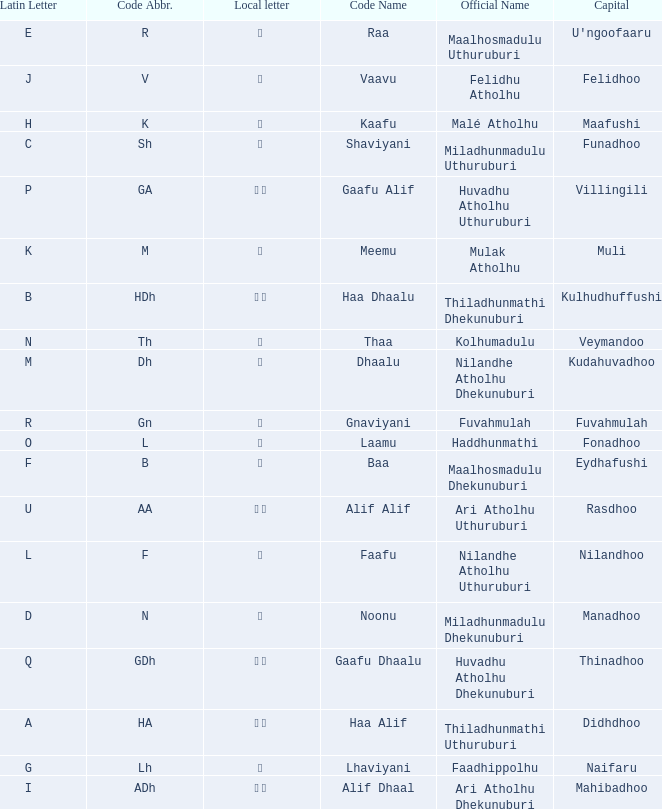The capital of funadhoo has what local letter? ށ. 